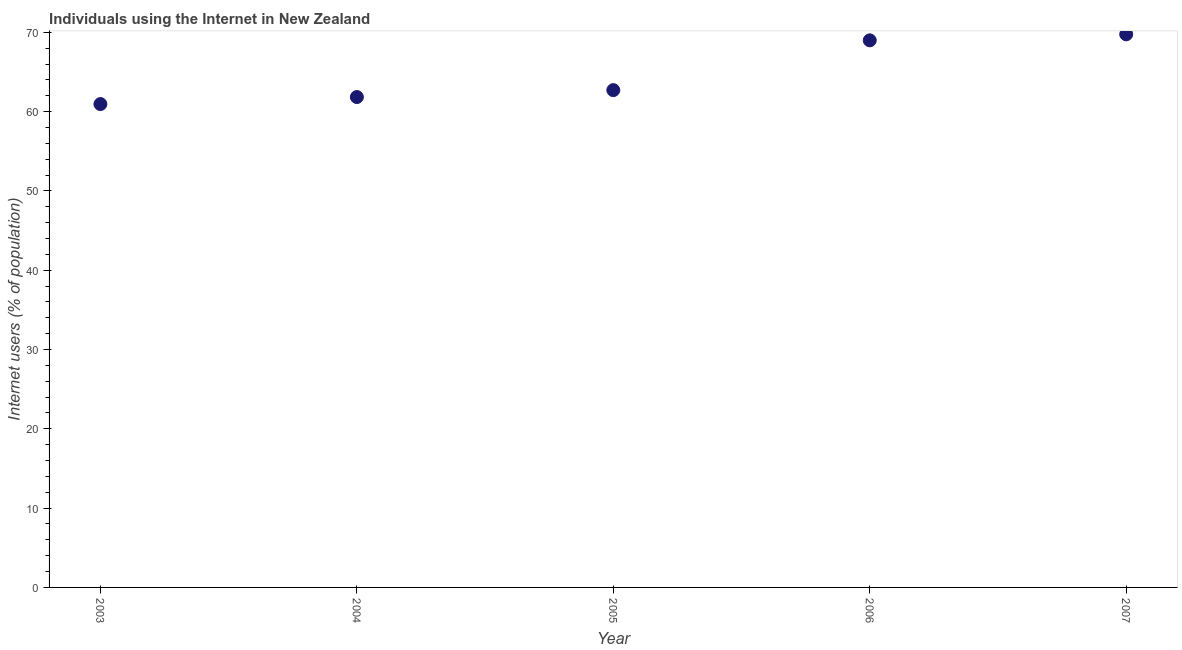What is the number of internet users in 2005?
Your answer should be very brief. 62.72. Across all years, what is the maximum number of internet users?
Keep it short and to the point. 69.76. Across all years, what is the minimum number of internet users?
Keep it short and to the point. 60.96. In which year was the number of internet users maximum?
Give a very brief answer. 2007. In which year was the number of internet users minimum?
Make the answer very short. 2003. What is the sum of the number of internet users?
Make the answer very short. 324.29. What is the difference between the number of internet users in 2005 and 2007?
Your answer should be very brief. -7.04. What is the average number of internet users per year?
Keep it short and to the point. 64.86. What is the median number of internet users?
Keep it short and to the point. 62.72. In how many years, is the number of internet users greater than 26 %?
Offer a very short reply. 5. What is the ratio of the number of internet users in 2004 to that in 2007?
Your answer should be very brief. 0.89. What is the difference between the highest and the second highest number of internet users?
Ensure brevity in your answer.  0.76. Is the sum of the number of internet users in 2004 and 2006 greater than the maximum number of internet users across all years?
Provide a succinct answer. Yes. What is the difference between the highest and the lowest number of internet users?
Your response must be concise. 8.8. Does the number of internet users monotonically increase over the years?
Provide a succinct answer. Yes. How many dotlines are there?
Provide a short and direct response. 1. How many years are there in the graph?
Keep it short and to the point. 5. Are the values on the major ticks of Y-axis written in scientific E-notation?
Your answer should be compact. No. Does the graph contain grids?
Give a very brief answer. No. What is the title of the graph?
Your response must be concise. Individuals using the Internet in New Zealand. What is the label or title of the X-axis?
Ensure brevity in your answer.  Year. What is the label or title of the Y-axis?
Offer a very short reply. Internet users (% of population). What is the Internet users (% of population) in 2003?
Your answer should be compact. 60.96. What is the Internet users (% of population) in 2004?
Offer a terse response. 61.85. What is the Internet users (% of population) in 2005?
Make the answer very short. 62.72. What is the Internet users (% of population) in 2007?
Your response must be concise. 69.76. What is the difference between the Internet users (% of population) in 2003 and 2004?
Ensure brevity in your answer.  -0.89. What is the difference between the Internet users (% of population) in 2003 and 2005?
Give a very brief answer. -1.76. What is the difference between the Internet users (% of population) in 2003 and 2006?
Your answer should be very brief. -8.04. What is the difference between the Internet users (% of population) in 2003 and 2007?
Ensure brevity in your answer.  -8.8. What is the difference between the Internet users (% of population) in 2004 and 2005?
Your answer should be very brief. -0.87. What is the difference between the Internet users (% of population) in 2004 and 2006?
Offer a very short reply. -7.15. What is the difference between the Internet users (% of population) in 2004 and 2007?
Offer a terse response. -7.91. What is the difference between the Internet users (% of population) in 2005 and 2006?
Give a very brief answer. -6.28. What is the difference between the Internet users (% of population) in 2005 and 2007?
Provide a short and direct response. -7.04. What is the difference between the Internet users (% of population) in 2006 and 2007?
Keep it short and to the point. -0.76. What is the ratio of the Internet users (% of population) in 2003 to that in 2004?
Ensure brevity in your answer.  0.99. What is the ratio of the Internet users (% of population) in 2003 to that in 2006?
Your answer should be compact. 0.88. What is the ratio of the Internet users (% of population) in 2003 to that in 2007?
Keep it short and to the point. 0.87. What is the ratio of the Internet users (% of population) in 2004 to that in 2006?
Your answer should be compact. 0.9. What is the ratio of the Internet users (% of population) in 2004 to that in 2007?
Provide a succinct answer. 0.89. What is the ratio of the Internet users (% of population) in 2005 to that in 2006?
Your answer should be compact. 0.91. What is the ratio of the Internet users (% of population) in 2005 to that in 2007?
Your response must be concise. 0.9. What is the ratio of the Internet users (% of population) in 2006 to that in 2007?
Offer a very short reply. 0.99. 